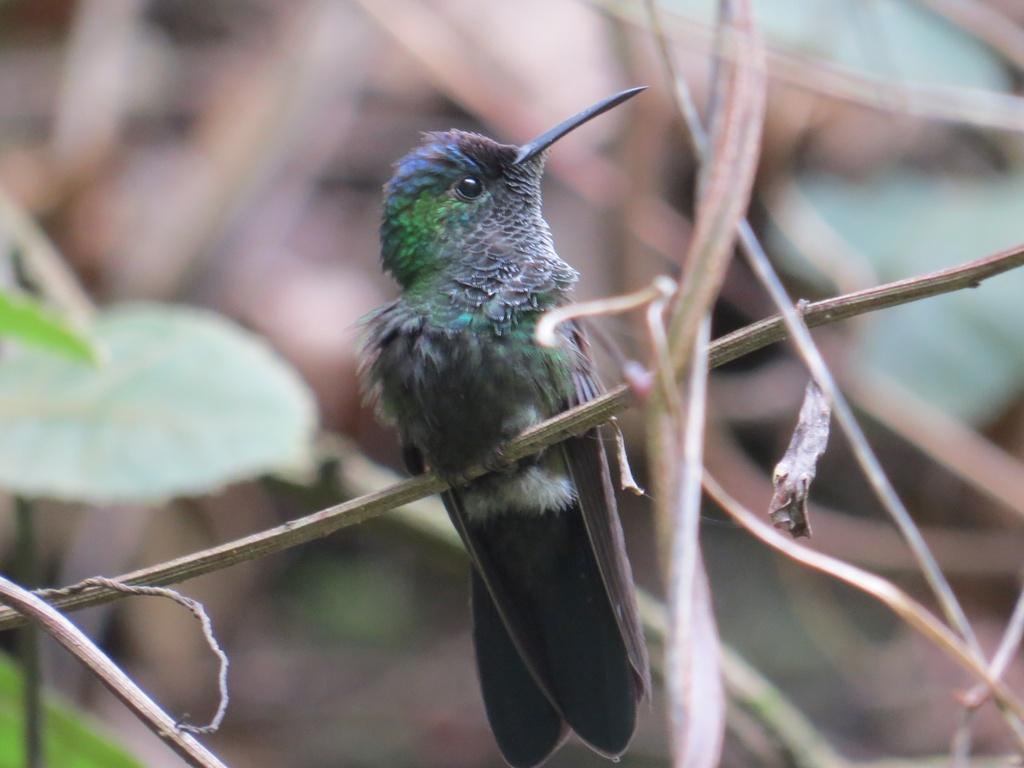What type of bird is in the image? There is a black color bird in the image. Where is the bird located in the image? The bird is in the middle of the image. What else can be seen on the left side of the image? There is a leaf on the left side of the image. How many clocks are visible in the image? There are no clocks visible in the image. What type of seed is the bird holding in its beak? The bird does not have a seed in its beak, as there is no seed present in the image. 